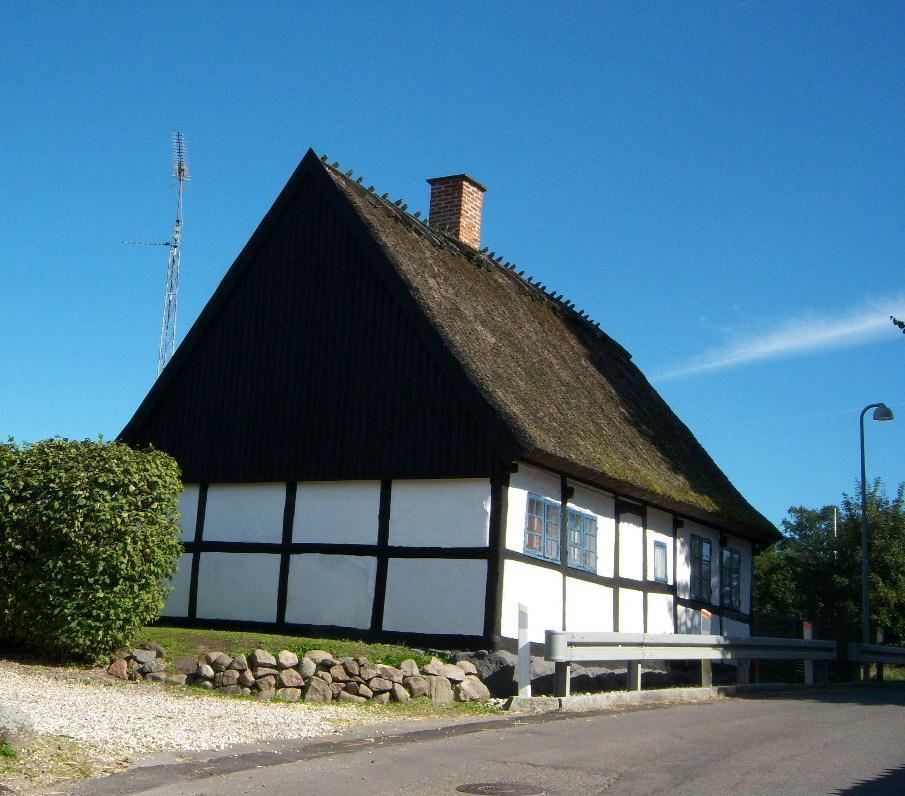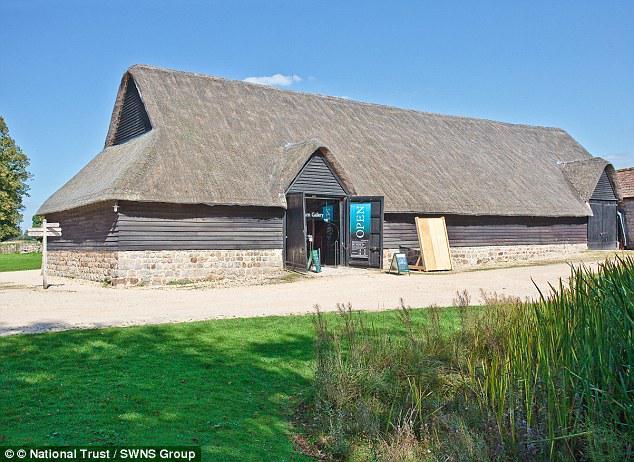The first image is the image on the left, the second image is the image on the right. Considering the images on both sides, is "The building in the image on the left has a chimney." valid? Answer yes or no. Yes. The first image is the image on the left, the second image is the image on the right. Given the left and right images, does the statement "The right image shows a long grey building with a peaked roof and an open door, but no windows, and the left image shows a building with a peaked roof and windows on the front." hold true? Answer yes or no. Yes. 